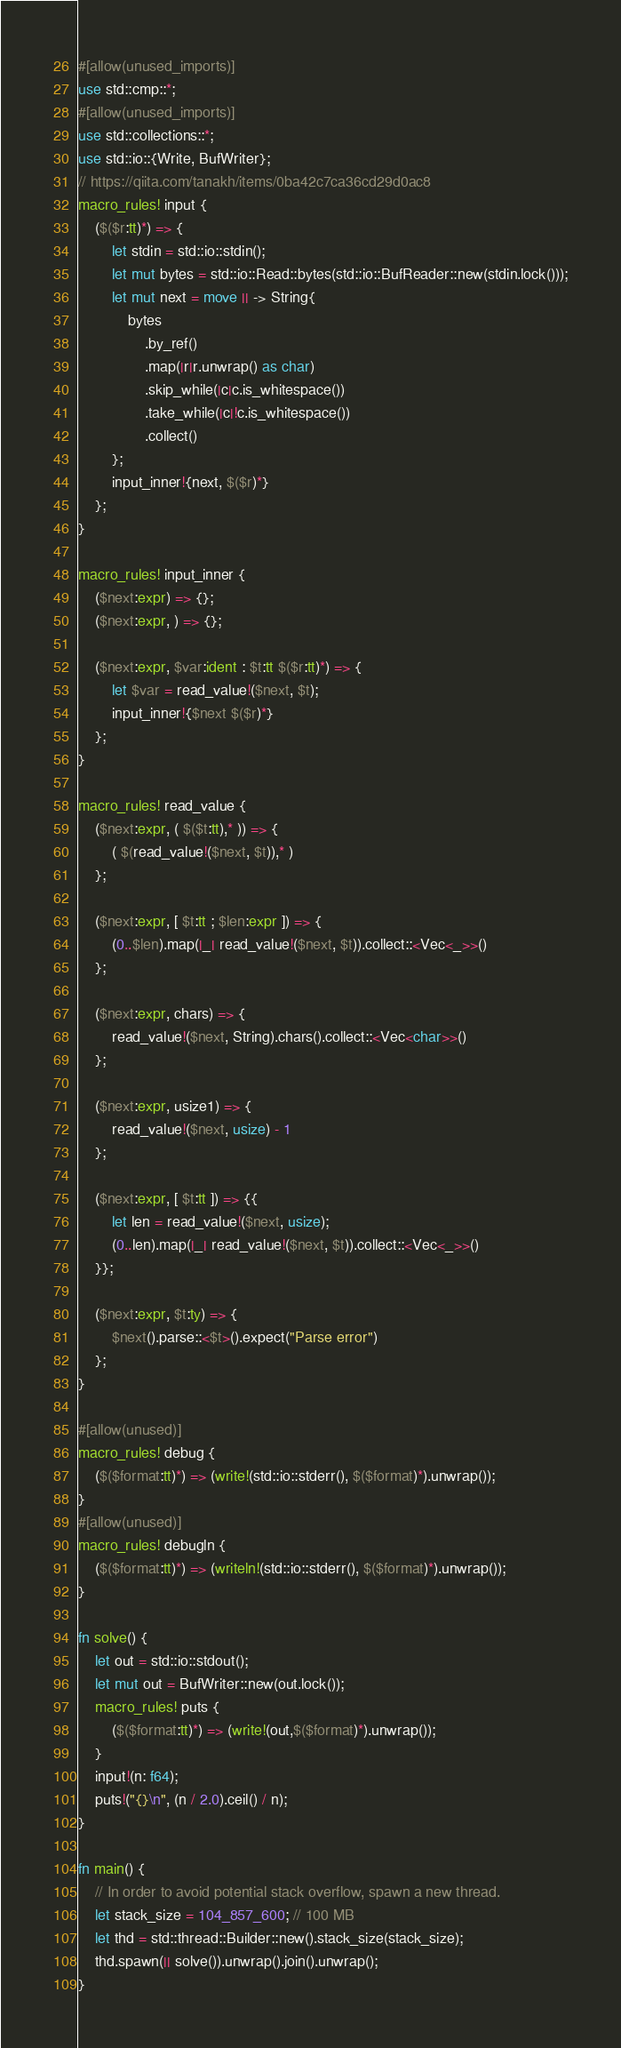Convert code to text. <code><loc_0><loc_0><loc_500><loc_500><_Rust_>#[allow(unused_imports)]
use std::cmp::*;
#[allow(unused_imports)]
use std::collections::*;
use std::io::{Write, BufWriter};
// https://qiita.com/tanakh/items/0ba42c7ca36cd29d0ac8
macro_rules! input {
    ($($r:tt)*) => {
        let stdin = std::io::stdin();
        let mut bytes = std::io::Read::bytes(std::io::BufReader::new(stdin.lock()));
        let mut next = move || -> String{
            bytes
                .by_ref()
                .map(|r|r.unwrap() as char)
                .skip_while(|c|c.is_whitespace())
                .take_while(|c|!c.is_whitespace())
                .collect()
        };
        input_inner!{next, $($r)*}
    };
}

macro_rules! input_inner {
    ($next:expr) => {};
    ($next:expr, ) => {};

    ($next:expr, $var:ident : $t:tt $($r:tt)*) => {
        let $var = read_value!($next, $t);
        input_inner!{$next $($r)*}
    };
}

macro_rules! read_value {
    ($next:expr, ( $($t:tt),* )) => {
        ( $(read_value!($next, $t)),* )
    };

    ($next:expr, [ $t:tt ; $len:expr ]) => {
        (0..$len).map(|_| read_value!($next, $t)).collect::<Vec<_>>()
    };

    ($next:expr, chars) => {
        read_value!($next, String).chars().collect::<Vec<char>>()
    };

    ($next:expr, usize1) => {
        read_value!($next, usize) - 1
    };

    ($next:expr, [ $t:tt ]) => {{
        let len = read_value!($next, usize);
        (0..len).map(|_| read_value!($next, $t)).collect::<Vec<_>>()
    }};

    ($next:expr, $t:ty) => {
        $next().parse::<$t>().expect("Parse error")
    };
}

#[allow(unused)]
macro_rules! debug {
    ($($format:tt)*) => (write!(std::io::stderr(), $($format)*).unwrap());
}
#[allow(unused)]
macro_rules! debugln {
    ($($format:tt)*) => (writeln!(std::io::stderr(), $($format)*).unwrap());
}

fn solve() {
    let out = std::io::stdout();
    let mut out = BufWriter::new(out.lock());
    macro_rules! puts {
        ($($format:tt)*) => (write!(out,$($format)*).unwrap());
    }
    input!(n: f64);
    puts!("{}\n", (n / 2.0).ceil() / n);
}

fn main() {
    // In order to avoid potential stack overflow, spawn a new thread.
    let stack_size = 104_857_600; // 100 MB
    let thd = std::thread::Builder::new().stack_size(stack_size);
    thd.spawn(|| solve()).unwrap().join().unwrap();
}
</code> 